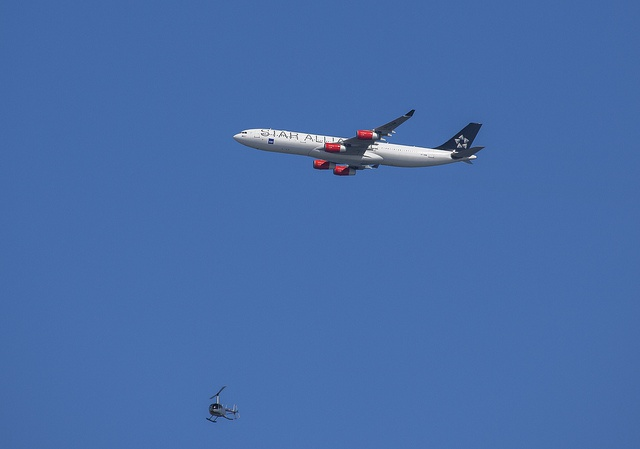Describe the objects in this image and their specific colors. I can see a airplane in blue, gray, lightgray, and black tones in this image. 